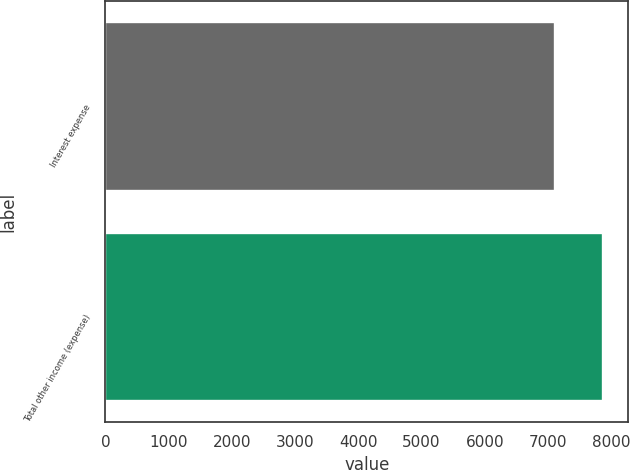<chart> <loc_0><loc_0><loc_500><loc_500><bar_chart><fcel>Interest expense<fcel>Total other income (expense)<nl><fcel>7119<fcel>7873<nl></chart> 